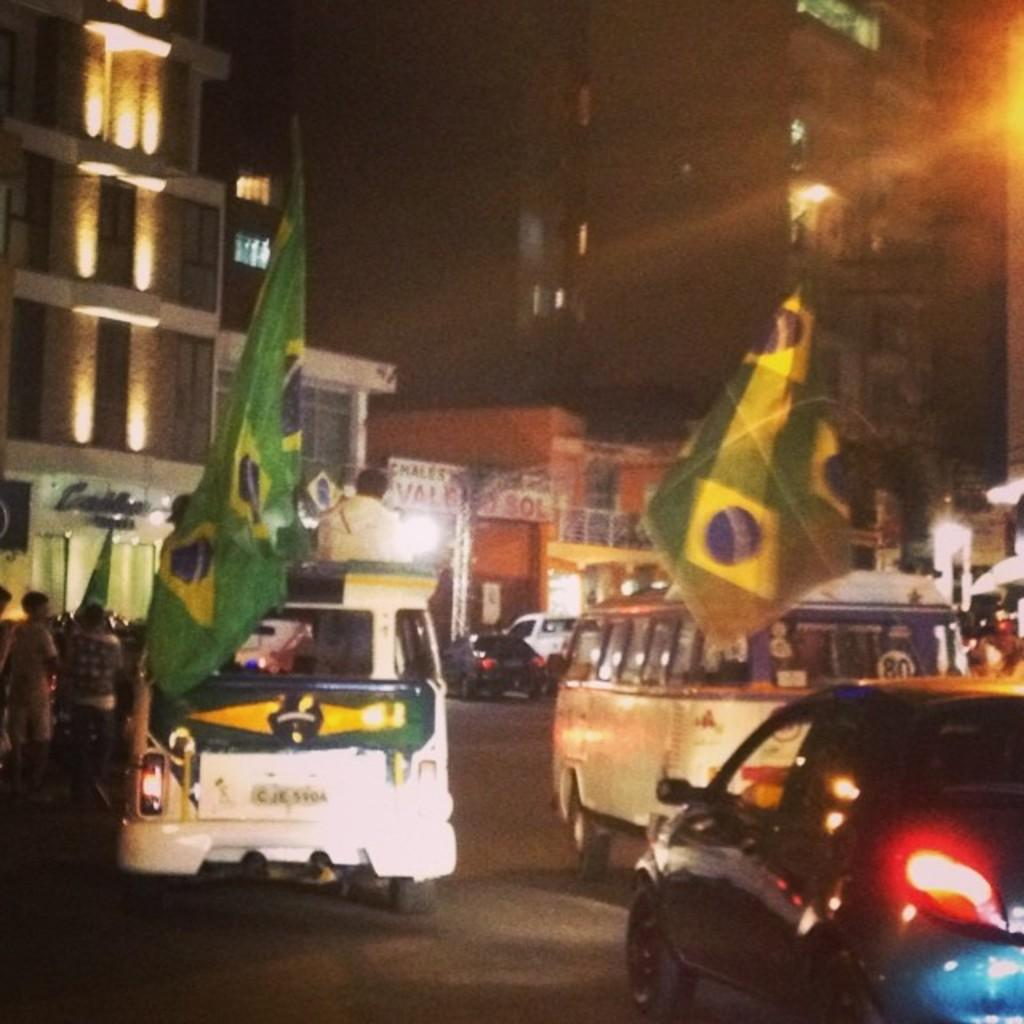<image>
Relay a brief, clear account of the picture shown. The first letter on the license plate read C. 